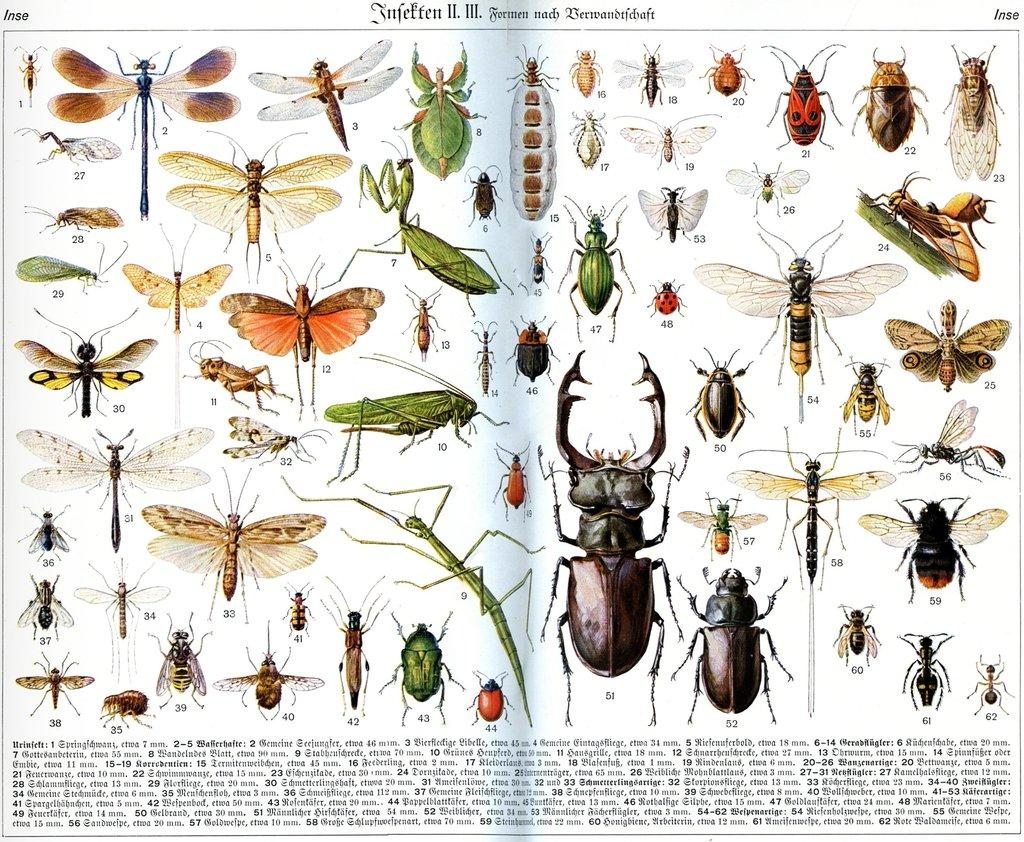What is depicted on the poster in the image? The poster contains a dragonfly, a fly, an ant, and other insects. What type of creatures are featured on the poster? The poster features insects, including a dragonfly, a fly, and an ant. Is there any text on the poster? Yes, there is text at the bottom of the poster. Can you see a goldfish swimming in the image? No, there is no goldfish present in the image. Is there a crook in the image trying to steal the insects from the poster? No, there is no crook or theft depicted in the image. 